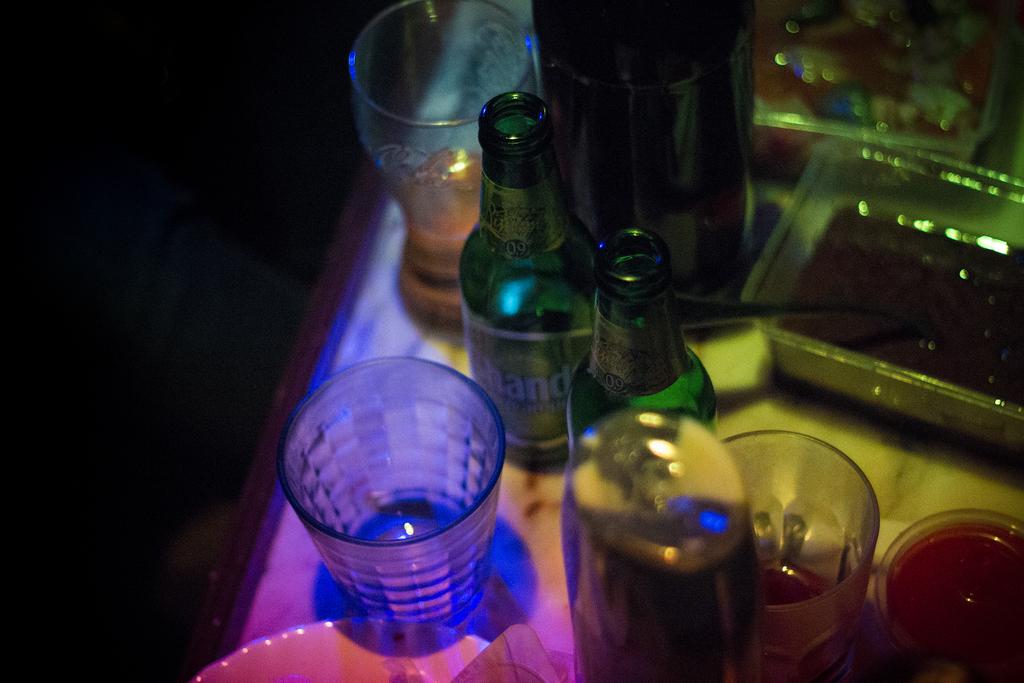What number is on the top of the beer bottles?
Offer a terse response. Unanswerable. 